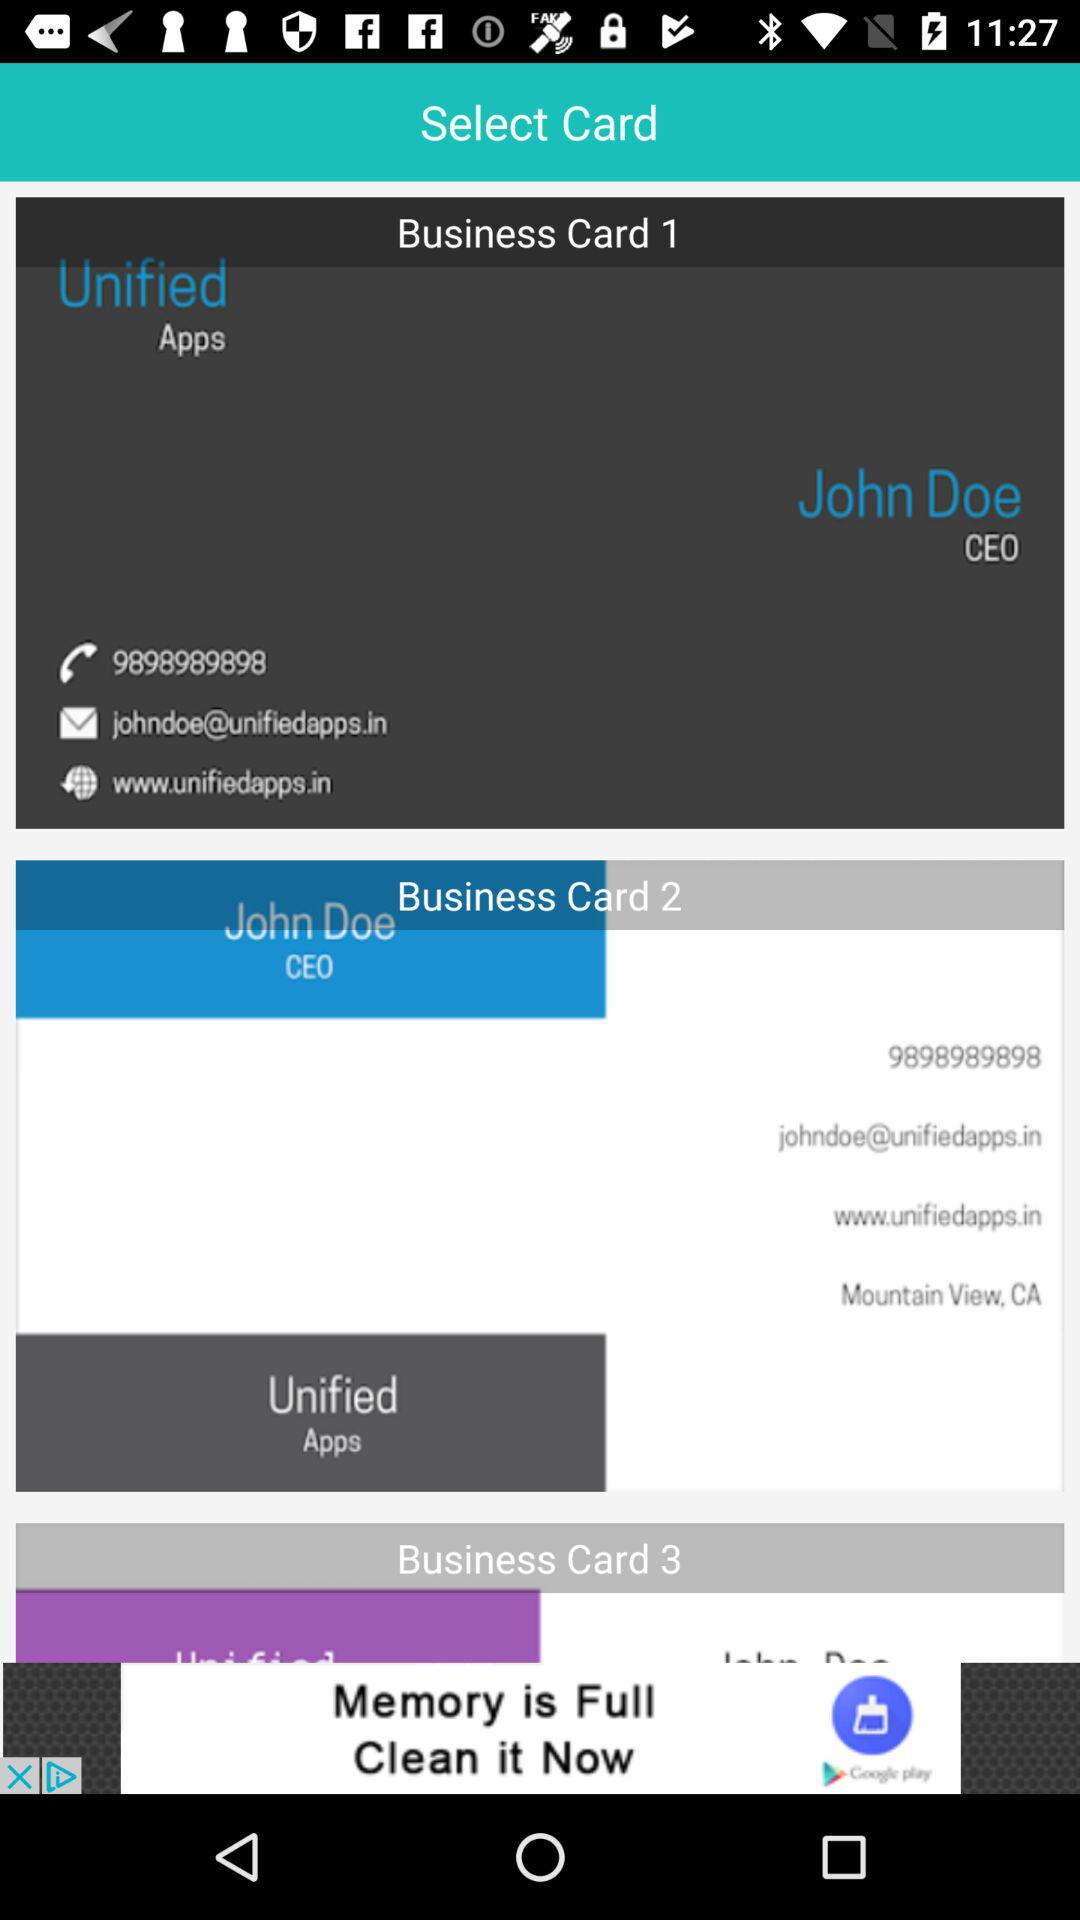Who's the CEO? The CEO is John Doe. 